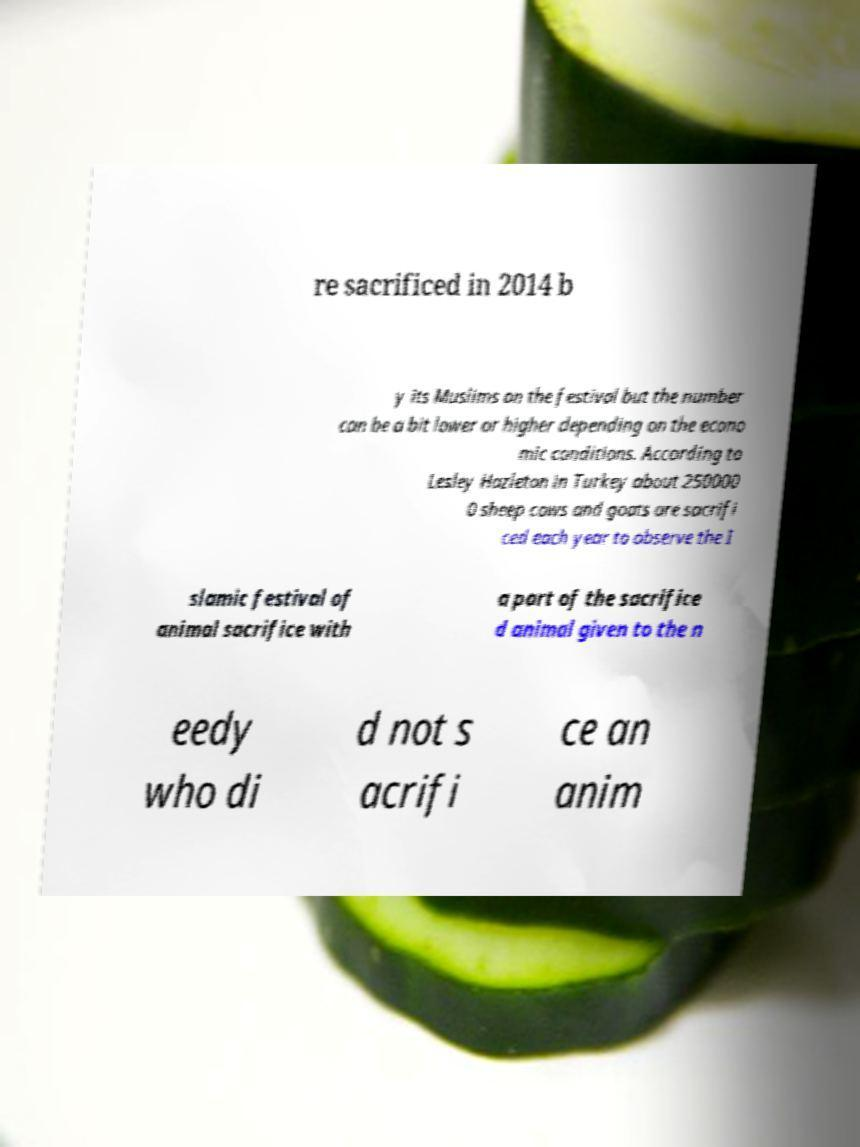Can you accurately transcribe the text from the provided image for me? re sacrificed in 2014 b y its Muslims on the festival but the number can be a bit lower or higher depending on the econo mic conditions. According to Lesley Hazleton in Turkey about 250000 0 sheep cows and goats are sacrifi ced each year to observe the I slamic festival of animal sacrifice with a part of the sacrifice d animal given to the n eedy who di d not s acrifi ce an anim 